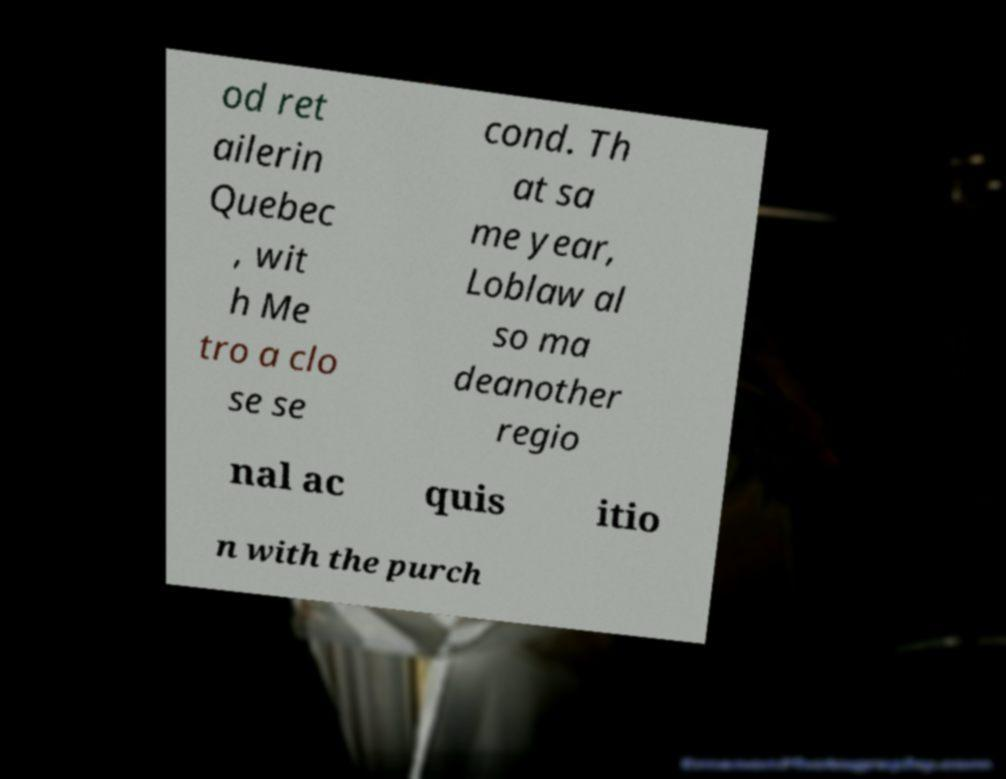Please identify and transcribe the text found in this image. od ret ailerin Quebec , wit h Me tro a clo se se cond. Th at sa me year, Loblaw al so ma deanother regio nal ac quis itio n with the purch 